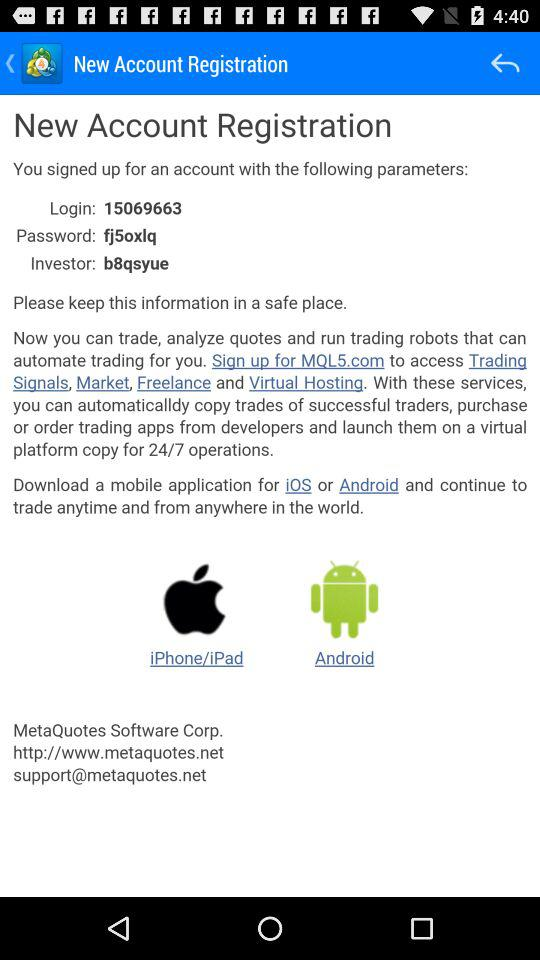How many services are available on MQL5.com?
Answer the question using a single word or phrase. 4 